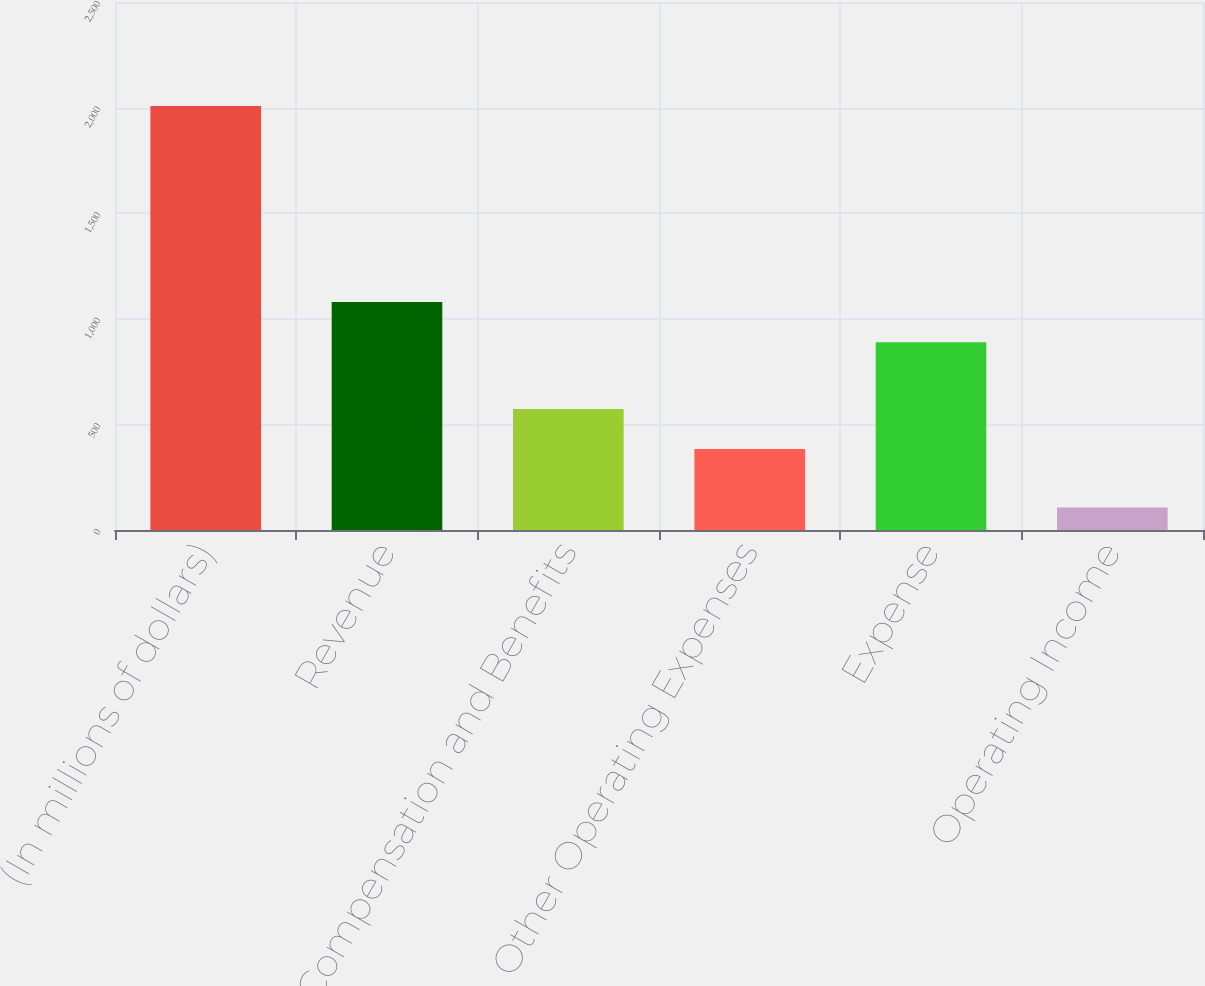Convert chart. <chart><loc_0><loc_0><loc_500><loc_500><bar_chart><fcel>(In millions of dollars)<fcel>Revenue<fcel>Compensation and Benefits<fcel>Other Operating Expenses<fcel>Expense<fcel>Operating Income<nl><fcel>2007<fcel>1079.1<fcel>573.1<fcel>383<fcel>889<fcel>106<nl></chart> 